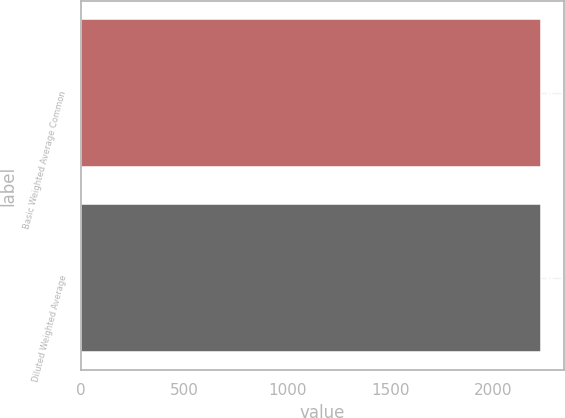Convert chart to OTSL. <chart><loc_0><loc_0><loc_500><loc_500><bar_chart><fcel>Basic Weighted Average Common<fcel>Diluted Weighted Average<nl><fcel>2230<fcel>2230.1<nl></chart> 